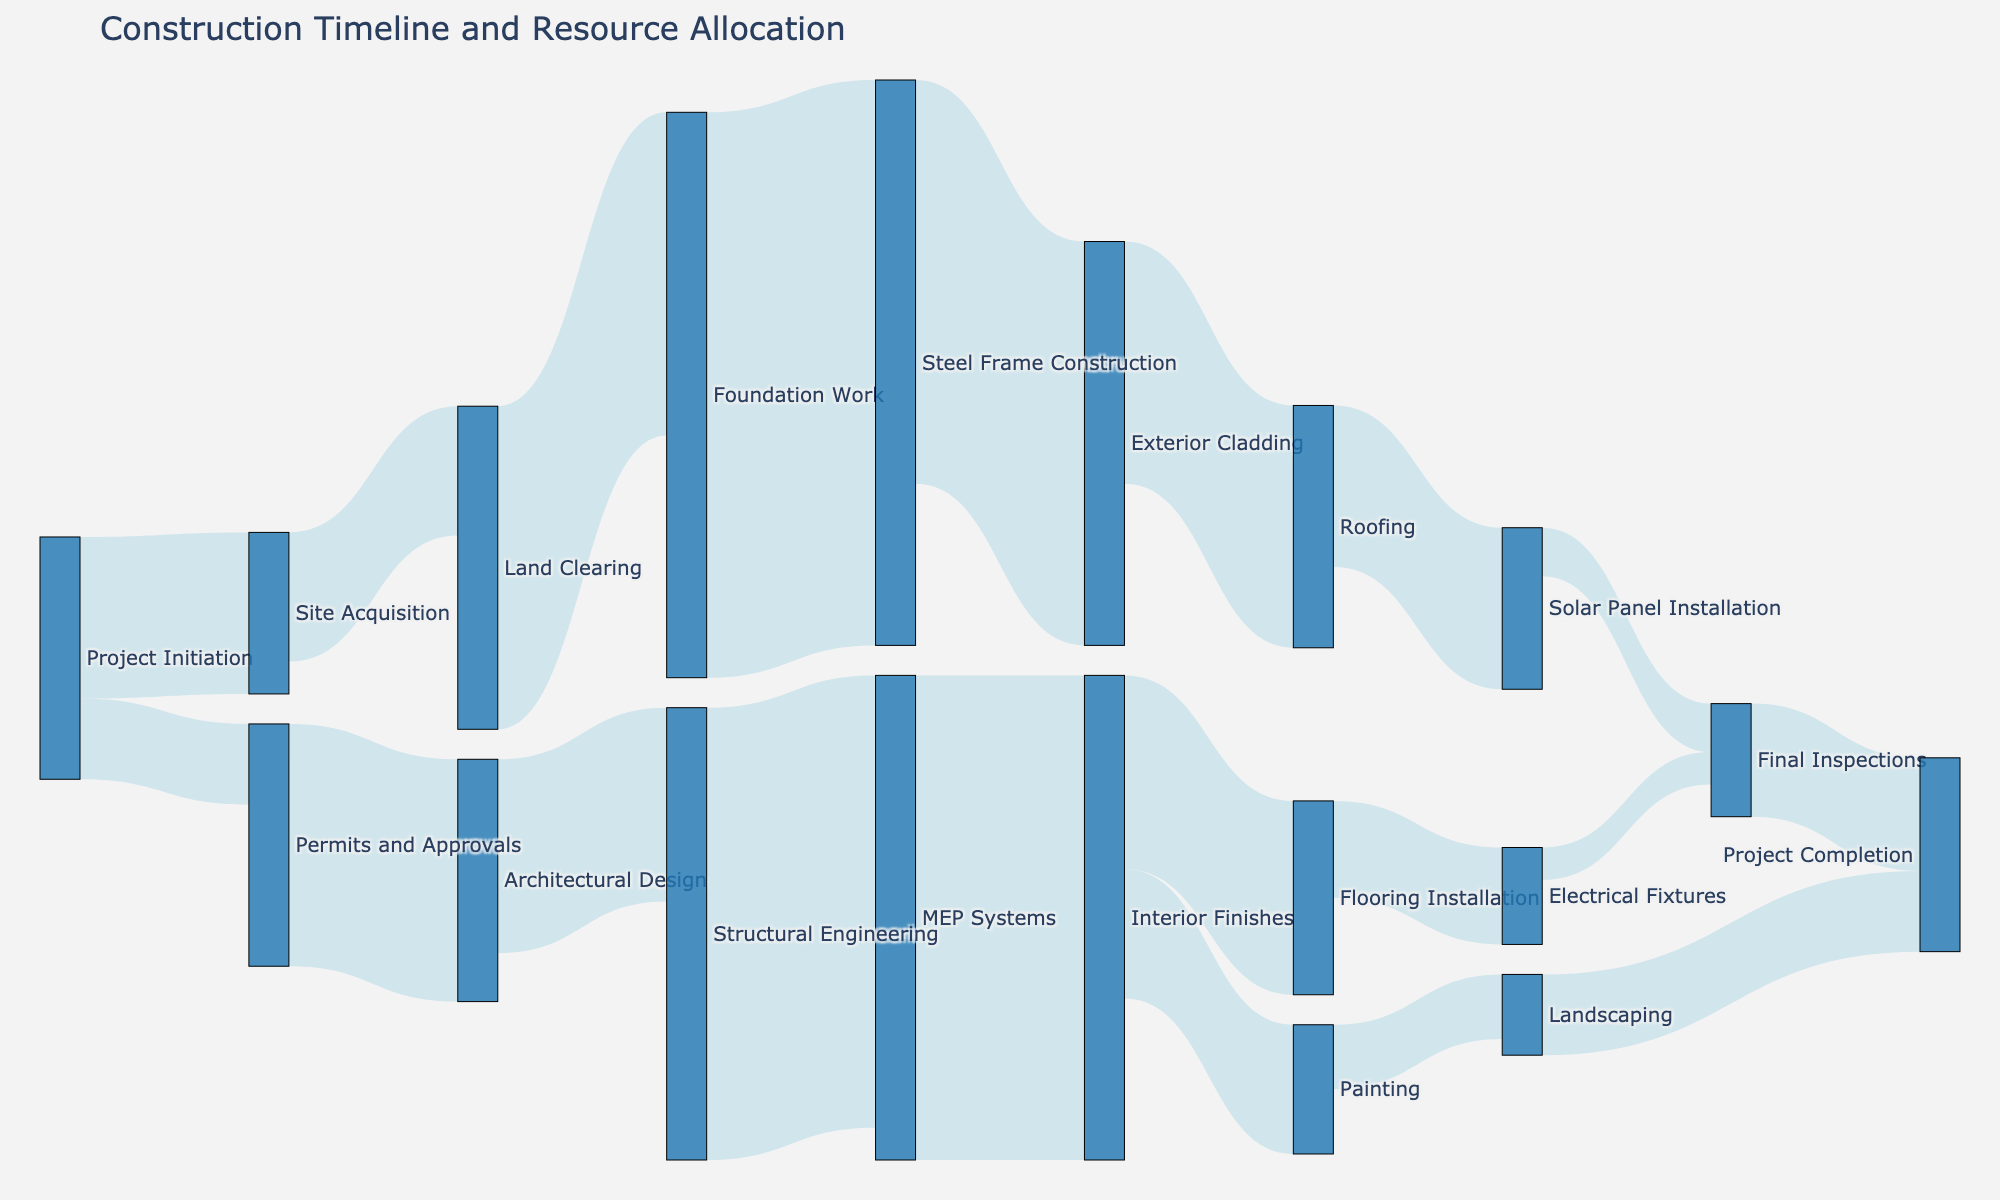What is the title of the Sankey diagram? The title of the Sankey diagram is displayed at the top of the image and provides an overview of what the diagram represents.
Answer: Construction Timeline and Resource Allocation What is the total resource allocation for the Final Inspections stage? To determine this, sum up the values flowing into 'Final Inspections', which are from ‘Solar Panel Installation’ and ‘Electrical Fixtures’. The values are 300,000 and 200,000 respectively. So, 300,000 + 200,000.
Answer: 500,000 Which stage has the highest resource allocation and how much is it? By examining the values connected to the target nodes, 'MEP Systems' received 2,800,000, which is the largest single allocation.
Answer: MEP Systems, 2,800,000 Compare the resource allocation between 'Foundation Work' and 'Steel Frame Construction'. Which one received more resources? Identify the values assigned to 'Foundation Work' and 'Steel Frame Construction'. 'Foundation Work' received 2,000,000 and 'Steel Frame Construction' received 3,500,000. Comparatively, 'Steel Frame Construction' received more.
Answer: Steel Frame Construction How much more resources are allocated to 'Interior Finishes' compared to 'Painting'? Look at the values for 'Interior Finishes' and 'Painting'. 'Interior Finishes' received 3,000,000 and 'Painting' received 800,000. The difference is 3,000,000 - 800,000.
Answer: 2,200,000 What is the total resource allocation for the structural related activities ('Architectural Design', 'Structural Engineering', 'Steel Frame Construction')? Sum up the values associated with these stages: 'Architectural Design' (1,500,000), 'Structural Engineering' (1,200,000), and 'Steel Frame Construction' (3,500,000). So, 1,500,000 + 1,200,000 + 3,500,000.
Answer: 6,200,000 Which stages directly precede 'Project Completion'? Identify the stages connected directly to 'Project Completion'. These are 'Landscaping' and 'Final Inspections'.
Answer: Landscaping, Final Inspections What proportion of the total resource allocation does 'Steel Frame Construction' represent? First, calculate the total resource allocation by summing up all the values, then determine the proportion of 'Steel Frame Construction'. The total is 1000000 + 500000 + 800000 + 1500000 + 2000000 + 1200000 + 3500000 + 2800000 + 2500000 + 3000000 + 1500000 + 1200000 + 800000 + 1000000 + 600000 + 400000 + 300000 + 200000 + 500000 + 700000 = 25100000. The value for 'Steel Frame Construction' is 3500000. The proportion is 3500000 / 25100000.
Answer: 0.1394 or 13.94% 